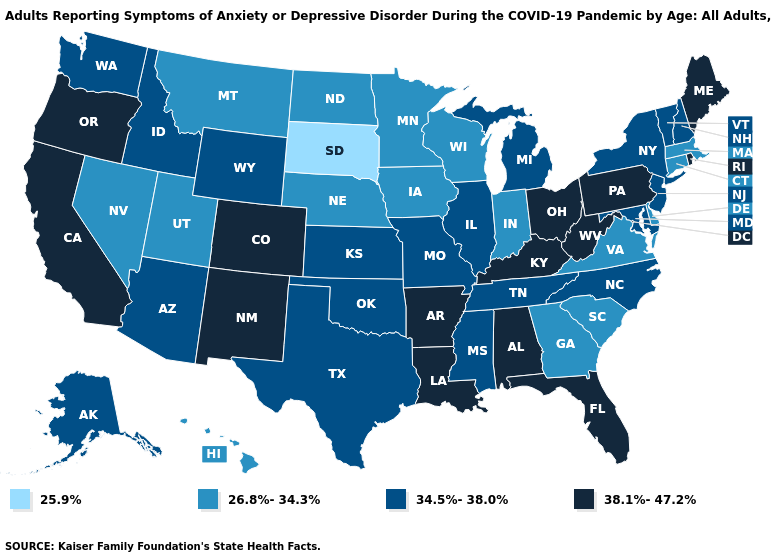What is the value of Connecticut?
Short answer required. 26.8%-34.3%. What is the value of Hawaii?
Quick response, please. 26.8%-34.3%. Does South Dakota have the lowest value in the MidWest?
Be succinct. Yes. Which states have the lowest value in the South?
Write a very short answer. Delaware, Georgia, South Carolina, Virginia. What is the lowest value in the Northeast?
Answer briefly. 26.8%-34.3%. Name the states that have a value in the range 38.1%-47.2%?
Write a very short answer. Alabama, Arkansas, California, Colorado, Florida, Kentucky, Louisiana, Maine, New Mexico, Ohio, Oregon, Pennsylvania, Rhode Island, West Virginia. Name the states that have a value in the range 34.5%-38.0%?
Short answer required. Alaska, Arizona, Idaho, Illinois, Kansas, Maryland, Michigan, Mississippi, Missouri, New Hampshire, New Jersey, New York, North Carolina, Oklahoma, Tennessee, Texas, Vermont, Washington, Wyoming. Does South Dakota have the lowest value in the MidWest?
Answer briefly. Yes. Does Indiana have a lower value than Tennessee?
Give a very brief answer. Yes. Name the states that have a value in the range 38.1%-47.2%?
Keep it brief. Alabama, Arkansas, California, Colorado, Florida, Kentucky, Louisiana, Maine, New Mexico, Ohio, Oregon, Pennsylvania, Rhode Island, West Virginia. What is the lowest value in the USA?
Keep it brief. 25.9%. Does West Virginia have the lowest value in the USA?
Write a very short answer. No. What is the value of Michigan?
Give a very brief answer. 34.5%-38.0%. Which states have the highest value in the USA?
Concise answer only. Alabama, Arkansas, California, Colorado, Florida, Kentucky, Louisiana, Maine, New Mexico, Ohio, Oregon, Pennsylvania, Rhode Island, West Virginia. What is the value of Oregon?
Be succinct. 38.1%-47.2%. 